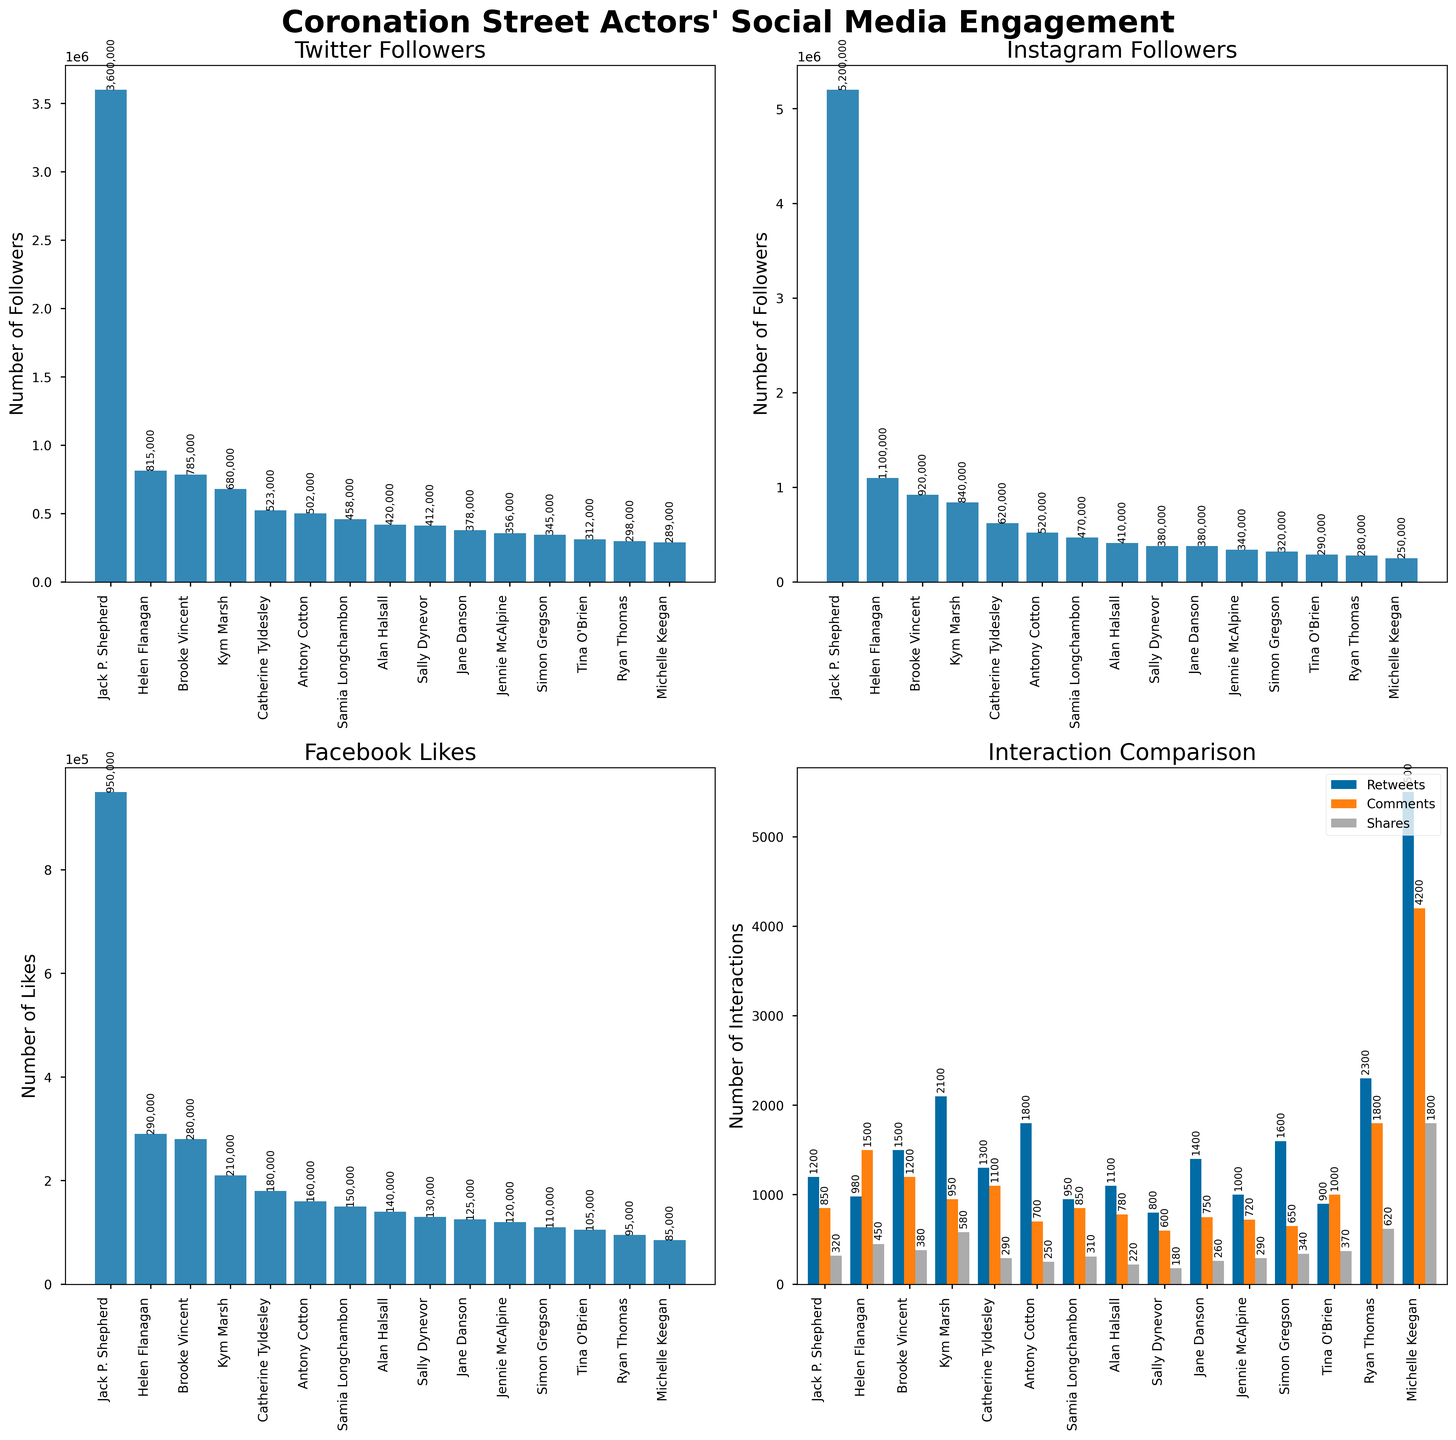Which actor has the most Twitter followers? Check the Twitter section of the plot and identify the highest bar. The label under this bar shows the actor's name.
Answer: Michelle Keegan How many Twitter followers do Jack P. Shepherd and Alan Halsall have in total? Find the Twitter follower counts for both Jack P. Shepherd and Alan Halsall in the Twitter plot. Add their follower counts: 458,000 (Jack P. Shepherd) + 345,000 (Alan Halsall) = 803,000.
Answer: 803,000 Which platform shows the highest number of interactions for Michelle Keegan? Compare the heights of the bars associated with Michelle Keegan in the 'Interaction Comparison' plot for Twitter retweets, Instagram comments, and Facebook shares. The tallest bar indicates the highest number of interactions.
Answer: Instagram What is the difference in Instagram followers between Helen Flanagan and Kym Marsh? Look at the Instagram followers' bars for Helen Flanagan and Kym Marsh. Subtract Kym Marsh's followers from Helen Flanagan's: 920,000 (Helen Flanagan) - 470,000 (Kym Marsh) = 450,000.
Answer: 450,000 Which actor receives the least number of Facebook likes? Find the shortest bar in the Facebook likes section and check the corresponding actor's name.
Answer: Sally Dynevor How many more Instagram comments does Ryan Thomas have compared to Helen Flanagan? Locate the Instagram comments for both Ryan Thomas and Helen Flanagan. Subtract Helen Flanagan’s comments from Ryan Thomas’s: 1,800 (Ryan Thomas) - 1,500 (Helen Flanagan) = 300.
Answer: 300 Which platform does Simon Gregson have the highest engagement on, according to the interaction comparison? Check the 'Interaction Comparison' plot for the bars representing Simon Gregson. Compare the heights of the bars to determine which platform has the highest value.
Answer: Twitter How many Facebook shares do Antony Cotton and Jane Danson have combined? Find the Facebook shares for both Antony Cotton and Jane Danson. Add their shares: 250 (Antony Cotton) + 260 (Jane Danson) = 510.
Answer: 510 Who has more Twitter retweets: Simon Gregson or Jennie McAlpine? Compare the Twitter retweets section for both Simon Gregson and Jennie McAlpine. Identify whose bar is taller.
Answer: Simon Gregson What is the average number of Facebook likes for Helen Flanagan, Brooke Vincent, and Tina O’Brien? Locate the Facebook likes for Helen Flanagan (210,000), Brooke Vincent (180,000), and Tina O’Brien (160,000). Sum these values and divide by 3: (210,000 + 180,000 + 160,000) / 3 = 183,333.33.
Answer: 183,333.33 What's the total number of retweets for the three actors with the highest Twitter followers? Identify the three actors with the highest Twitter followers: Michelle Keegan, Ryan Thomas, Kym Marsh. Sum their Twitter retweets: 5,500 (Michelle Keegan) + 2,300 (Ryan Thomas) + 2,100 (Kym Marsh) = 9,900.
Answer: 9,900 